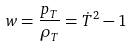Convert formula to latex. <formula><loc_0><loc_0><loc_500><loc_500>w = \frac { p _ { T } } { \rho _ { T } } = \dot { T } ^ { 2 } - 1</formula> 